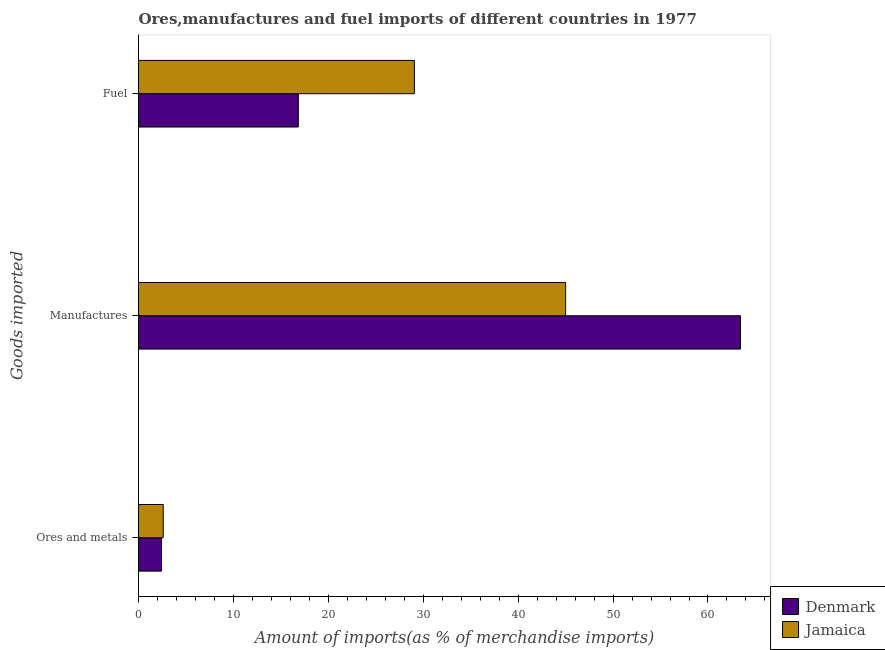Are the number of bars on each tick of the Y-axis equal?
Offer a terse response. Yes. What is the label of the 1st group of bars from the top?
Make the answer very short. Fuel. What is the percentage of fuel imports in Denmark?
Offer a terse response. 16.84. Across all countries, what is the maximum percentage of fuel imports?
Make the answer very short. 29.07. Across all countries, what is the minimum percentage of fuel imports?
Provide a short and direct response. 16.84. In which country was the percentage of ores and metals imports minimum?
Offer a very short reply. Denmark. What is the total percentage of fuel imports in the graph?
Give a very brief answer. 45.9. What is the difference between the percentage of fuel imports in Denmark and that in Jamaica?
Ensure brevity in your answer.  -12.23. What is the difference between the percentage of fuel imports in Jamaica and the percentage of ores and metals imports in Denmark?
Your response must be concise. 26.64. What is the average percentage of manufactures imports per country?
Offer a terse response. 54.21. What is the difference between the percentage of manufactures imports and percentage of ores and metals imports in Jamaica?
Give a very brief answer. 42.4. In how many countries, is the percentage of fuel imports greater than 32 %?
Provide a short and direct response. 0. What is the ratio of the percentage of ores and metals imports in Jamaica to that in Denmark?
Keep it short and to the point. 1.07. Is the percentage of manufactures imports in Denmark less than that in Jamaica?
Provide a short and direct response. No. What is the difference between the highest and the second highest percentage of ores and metals imports?
Provide a succinct answer. 0.18. What is the difference between the highest and the lowest percentage of manufactures imports?
Your answer should be very brief. 18.42. Is the sum of the percentage of fuel imports in Jamaica and Denmark greater than the maximum percentage of ores and metals imports across all countries?
Provide a succinct answer. Yes. What does the 2nd bar from the top in Fuel represents?
Keep it short and to the point. Denmark. What does the 1st bar from the bottom in Fuel represents?
Ensure brevity in your answer.  Denmark. Is it the case that in every country, the sum of the percentage of ores and metals imports and percentage of manufactures imports is greater than the percentage of fuel imports?
Your response must be concise. Yes. Are all the bars in the graph horizontal?
Make the answer very short. Yes. What is the difference between two consecutive major ticks on the X-axis?
Ensure brevity in your answer.  10. Are the values on the major ticks of X-axis written in scientific E-notation?
Give a very brief answer. No. Where does the legend appear in the graph?
Your answer should be compact. Bottom right. How are the legend labels stacked?
Offer a very short reply. Vertical. What is the title of the graph?
Offer a very short reply. Ores,manufactures and fuel imports of different countries in 1977. What is the label or title of the X-axis?
Make the answer very short. Amount of imports(as % of merchandise imports). What is the label or title of the Y-axis?
Your response must be concise. Goods imported. What is the Amount of imports(as % of merchandise imports) of Denmark in Ores and metals?
Give a very brief answer. 2.42. What is the Amount of imports(as % of merchandise imports) of Jamaica in Ores and metals?
Your answer should be very brief. 2.6. What is the Amount of imports(as % of merchandise imports) in Denmark in Manufactures?
Provide a succinct answer. 63.42. What is the Amount of imports(as % of merchandise imports) of Jamaica in Manufactures?
Make the answer very short. 45. What is the Amount of imports(as % of merchandise imports) of Denmark in Fuel?
Provide a succinct answer. 16.84. What is the Amount of imports(as % of merchandise imports) in Jamaica in Fuel?
Give a very brief answer. 29.07. Across all Goods imported, what is the maximum Amount of imports(as % of merchandise imports) in Denmark?
Give a very brief answer. 63.42. Across all Goods imported, what is the maximum Amount of imports(as % of merchandise imports) in Jamaica?
Your answer should be compact. 45. Across all Goods imported, what is the minimum Amount of imports(as % of merchandise imports) in Denmark?
Make the answer very short. 2.42. Across all Goods imported, what is the minimum Amount of imports(as % of merchandise imports) in Jamaica?
Your response must be concise. 2.6. What is the total Amount of imports(as % of merchandise imports) in Denmark in the graph?
Give a very brief answer. 82.68. What is the total Amount of imports(as % of merchandise imports) of Jamaica in the graph?
Offer a very short reply. 76.67. What is the difference between the Amount of imports(as % of merchandise imports) of Denmark in Ores and metals and that in Manufactures?
Provide a short and direct response. -61. What is the difference between the Amount of imports(as % of merchandise imports) in Jamaica in Ores and metals and that in Manufactures?
Provide a short and direct response. -42.4. What is the difference between the Amount of imports(as % of merchandise imports) of Denmark in Ores and metals and that in Fuel?
Your answer should be very brief. -14.41. What is the difference between the Amount of imports(as % of merchandise imports) of Jamaica in Ores and metals and that in Fuel?
Offer a very short reply. -26.46. What is the difference between the Amount of imports(as % of merchandise imports) in Denmark in Manufactures and that in Fuel?
Provide a succinct answer. 46.59. What is the difference between the Amount of imports(as % of merchandise imports) of Jamaica in Manufactures and that in Fuel?
Give a very brief answer. 15.94. What is the difference between the Amount of imports(as % of merchandise imports) of Denmark in Ores and metals and the Amount of imports(as % of merchandise imports) of Jamaica in Manufactures?
Ensure brevity in your answer.  -42.58. What is the difference between the Amount of imports(as % of merchandise imports) of Denmark in Ores and metals and the Amount of imports(as % of merchandise imports) of Jamaica in Fuel?
Offer a terse response. -26.64. What is the difference between the Amount of imports(as % of merchandise imports) of Denmark in Manufactures and the Amount of imports(as % of merchandise imports) of Jamaica in Fuel?
Ensure brevity in your answer.  34.36. What is the average Amount of imports(as % of merchandise imports) in Denmark per Goods imported?
Your answer should be compact. 27.56. What is the average Amount of imports(as % of merchandise imports) in Jamaica per Goods imported?
Offer a very short reply. 25.56. What is the difference between the Amount of imports(as % of merchandise imports) in Denmark and Amount of imports(as % of merchandise imports) in Jamaica in Ores and metals?
Offer a terse response. -0.18. What is the difference between the Amount of imports(as % of merchandise imports) in Denmark and Amount of imports(as % of merchandise imports) in Jamaica in Manufactures?
Provide a short and direct response. 18.42. What is the difference between the Amount of imports(as % of merchandise imports) of Denmark and Amount of imports(as % of merchandise imports) of Jamaica in Fuel?
Provide a succinct answer. -12.23. What is the ratio of the Amount of imports(as % of merchandise imports) of Denmark in Ores and metals to that in Manufactures?
Offer a terse response. 0.04. What is the ratio of the Amount of imports(as % of merchandise imports) in Jamaica in Ores and metals to that in Manufactures?
Offer a terse response. 0.06. What is the ratio of the Amount of imports(as % of merchandise imports) of Denmark in Ores and metals to that in Fuel?
Keep it short and to the point. 0.14. What is the ratio of the Amount of imports(as % of merchandise imports) of Jamaica in Ores and metals to that in Fuel?
Your answer should be compact. 0.09. What is the ratio of the Amount of imports(as % of merchandise imports) in Denmark in Manufactures to that in Fuel?
Your answer should be compact. 3.77. What is the ratio of the Amount of imports(as % of merchandise imports) of Jamaica in Manufactures to that in Fuel?
Make the answer very short. 1.55. What is the difference between the highest and the second highest Amount of imports(as % of merchandise imports) of Denmark?
Ensure brevity in your answer.  46.59. What is the difference between the highest and the second highest Amount of imports(as % of merchandise imports) of Jamaica?
Provide a short and direct response. 15.94. What is the difference between the highest and the lowest Amount of imports(as % of merchandise imports) in Denmark?
Give a very brief answer. 61. What is the difference between the highest and the lowest Amount of imports(as % of merchandise imports) in Jamaica?
Offer a terse response. 42.4. 